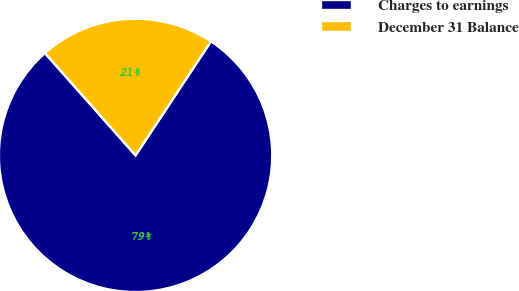<chart> <loc_0><loc_0><loc_500><loc_500><pie_chart><fcel>Charges to earnings<fcel>December 31 Balance<nl><fcel>79.17%<fcel>20.83%<nl></chart> 